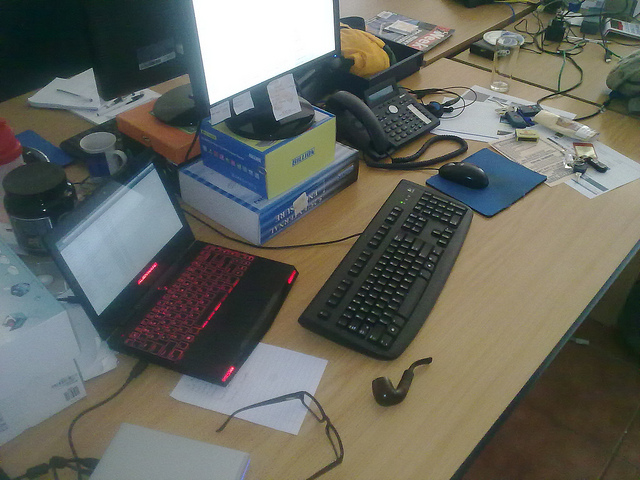What items on the desk suggest that someone might be a tech enthusiast or professional? The presence of multiple computer monitors, a mechanical keyboard, and a high-end gaming laptop with visible cooling vents suggest that the person using this workspace could be a tech enthusiast or professional. Additionally, there are several electronic gadgets and cables scattered across the desk, indicating a technical or gadget-oriented occupation or hobby. 